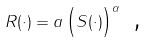<formula> <loc_0><loc_0><loc_500><loc_500>R ( \cdot ) = a \left ( \overset { \text { } } { S ( \cdot ) } \right ) ^ { \alpha } \text { ,}</formula> 